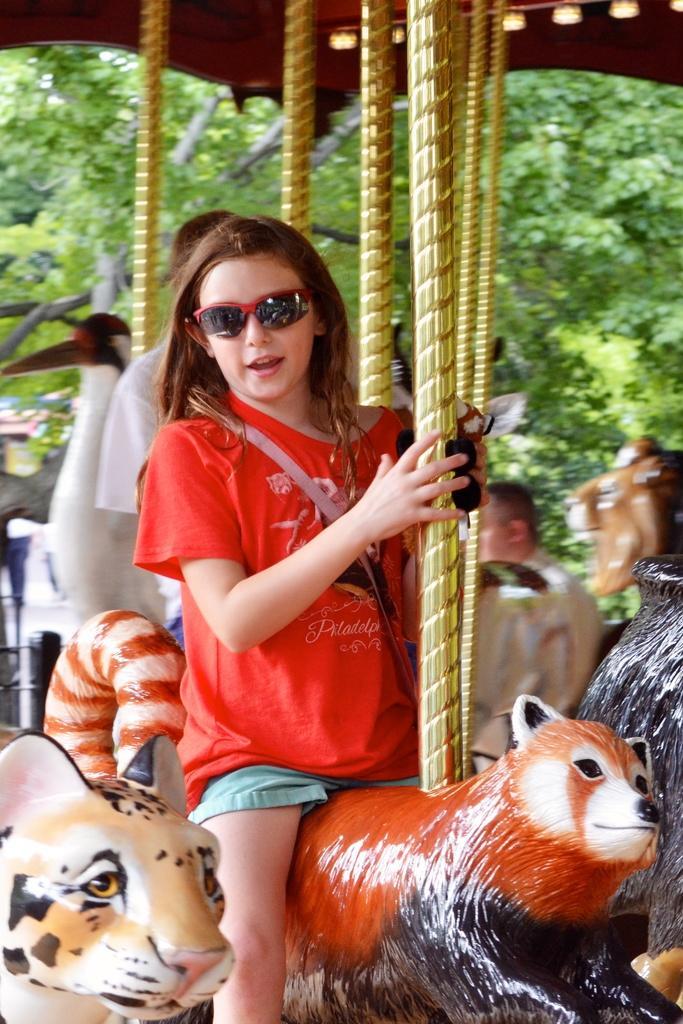Could you give a brief overview of what you see in this image? In this image we can see a girl wearing red t shirt and goggles is sitting on a ride and holding a pole in her hand. In the background we can see two persons ,group of poles ,trees and group of dolls. 